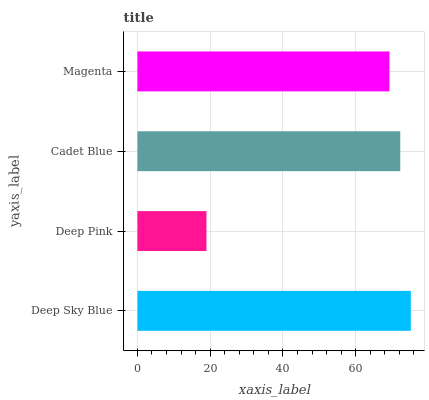Is Deep Pink the minimum?
Answer yes or no. Yes. Is Deep Sky Blue the maximum?
Answer yes or no. Yes. Is Cadet Blue the minimum?
Answer yes or no. No. Is Cadet Blue the maximum?
Answer yes or no. No. Is Cadet Blue greater than Deep Pink?
Answer yes or no. Yes. Is Deep Pink less than Cadet Blue?
Answer yes or no. Yes. Is Deep Pink greater than Cadet Blue?
Answer yes or no. No. Is Cadet Blue less than Deep Pink?
Answer yes or no. No. Is Cadet Blue the high median?
Answer yes or no. Yes. Is Magenta the low median?
Answer yes or no. Yes. Is Deep Sky Blue the high median?
Answer yes or no. No. Is Deep Pink the low median?
Answer yes or no. No. 